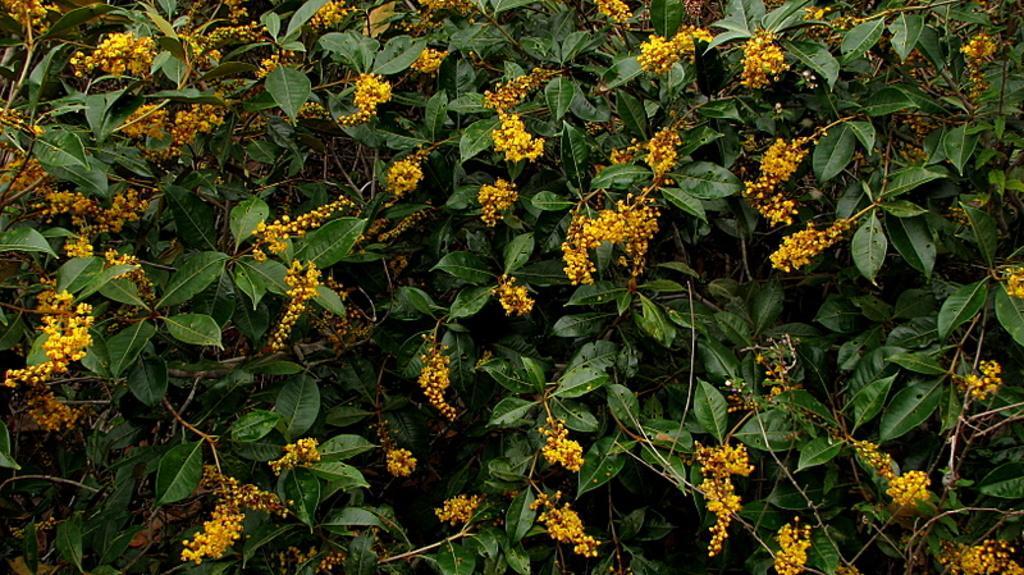Describe this image in one or two sentences. In this image we can see plants with flowers. 